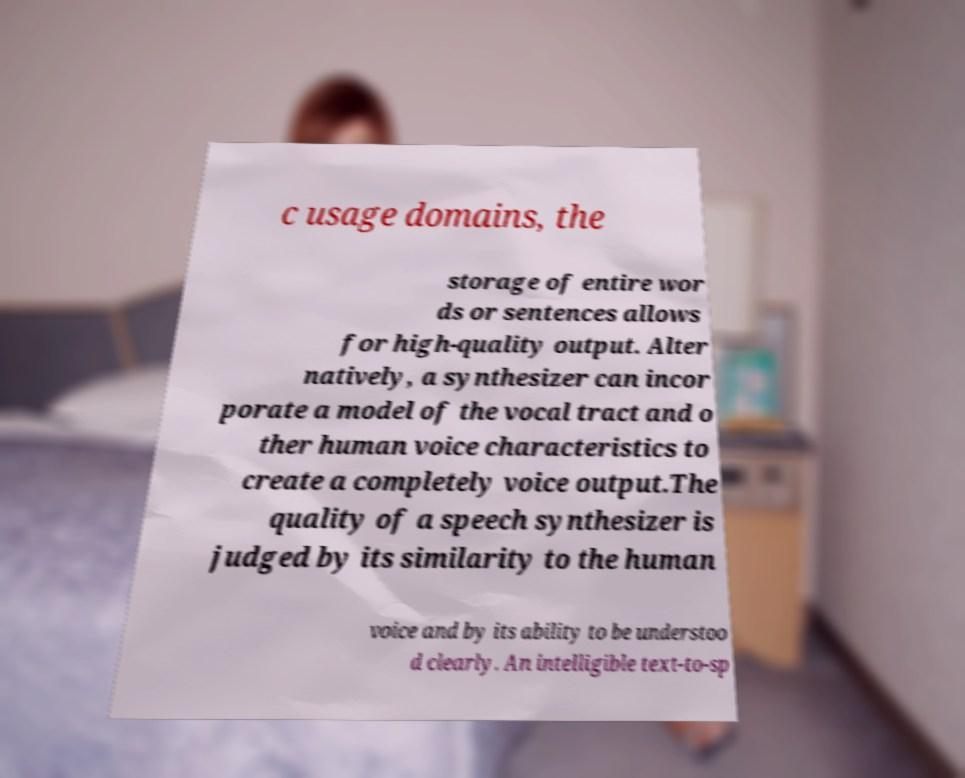Can you read and provide the text displayed in the image?This photo seems to have some interesting text. Can you extract and type it out for me? c usage domains, the storage of entire wor ds or sentences allows for high-quality output. Alter natively, a synthesizer can incor porate a model of the vocal tract and o ther human voice characteristics to create a completely voice output.The quality of a speech synthesizer is judged by its similarity to the human voice and by its ability to be understoo d clearly. An intelligible text-to-sp 